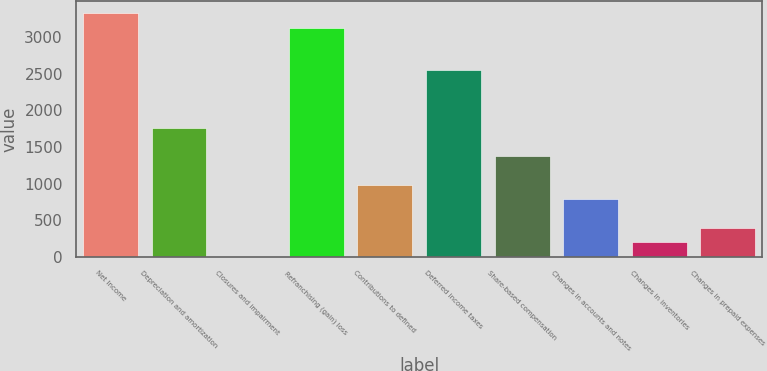Convert chart to OTSL. <chart><loc_0><loc_0><loc_500><loc_500><bar_chart><fcel>Net Income<fcel>Depreciation and amortization<fcel>Closures and impairment<fcel>Refranchising (gain) loss<fcel>Contributions to defined<fcel>Deferred income taxes<fcel>Share-based compensation<fcel>Changes in accounts and notes<fcel>Changes in inventories<fcel>Changes in prepaid expenses<nl><fcel>3329.9<fcel>1764.3<fcel>3<fcel>3134.2<fcel>981.5<fcel>2547.1<fcel>1372.9<fcel>785.8<fcel>198.7<fcel>394.4<nl></chart> 